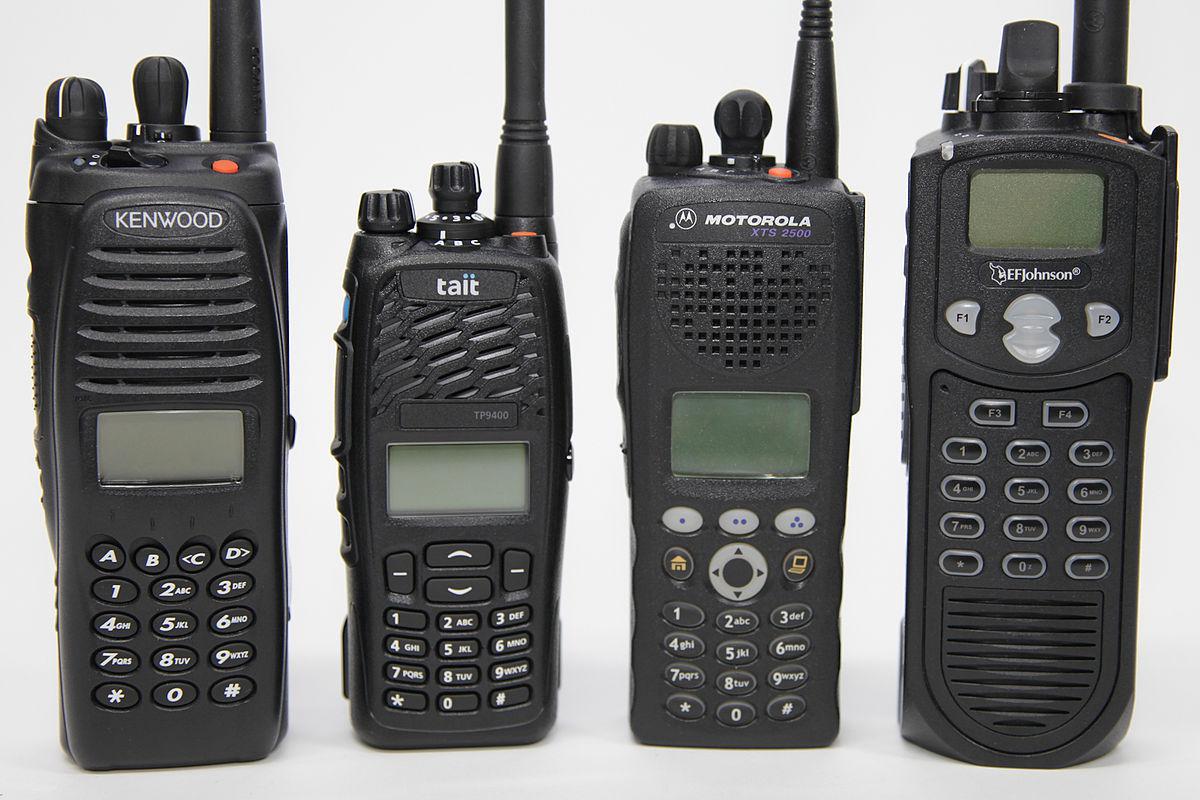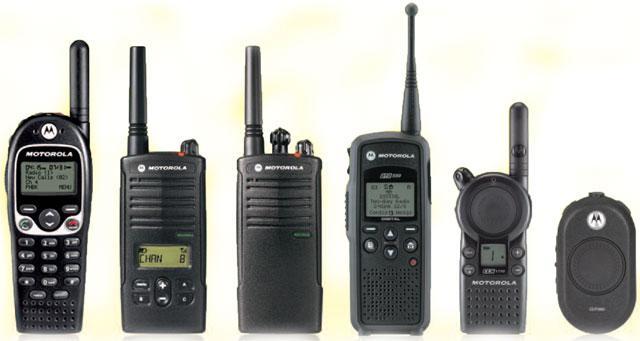The first image is the image on the left, the second image is the image on the right. Given the left and right images, does the statement "There are three walkie talkies." hold true? Answer yes or no. No. The first image is the image on the left, the second image is the image on the right. Analyze the images presented: Is the assertion "At least 3 walkie-talkies are lined up next to each other in each picture." valid? Answer yes or no. Yes. 